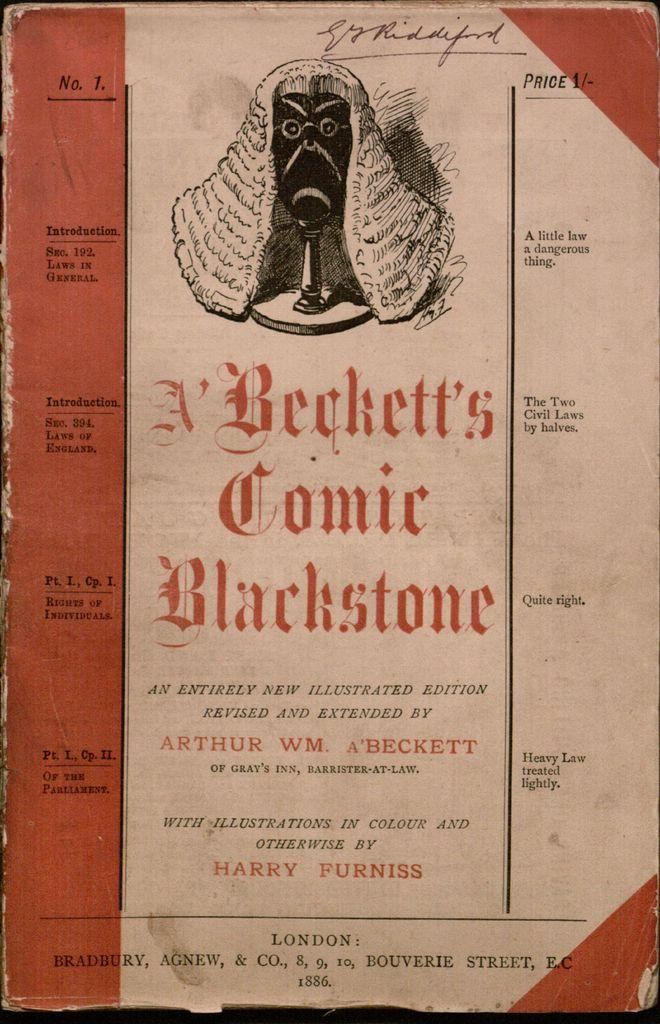<image>
Relay a brief, clear account of the picture shown. An old cover of A Beckett's Comic Blackstone/ 